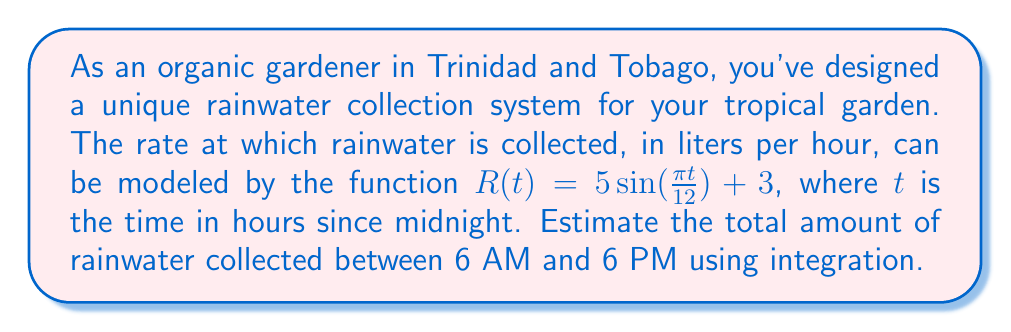Help me with this question. To solve this problem, we need to integrate the rate function $R(t)$ over the given time interval. Let's break it down step by step:

1) First, we need to set up the definite integral. The limits of integration are from 6 AM (6 hours after midnight) to 6 PM (18 hours after midnight):

   $$\int_{6}^{18} R(t) dt = \int_{6}^{18} (5\sin(\frac{\pi t}{12}) + 3) dt$$

2) We can split this into two integrals:

   $$\int_{6}^{18} 5\sin(\frac{\pi t}{12}) dt + \int_{6}^{18} 3 dt$$

3) Let's solve the second integral first, as it's simpler:

   $$\int_{6}^{18} 3 dt = 3t \big|_{6}^{18} = 3(18) - 3(6) = 54 - 18 = 36$$

4) Now for the first integral, we need to use substitution. Let $u = \frac{\pi t}{12}$, then $du = \frac{\pi}{12} dt$ or $dt = \frac{12}{\pi} du$:

   $$5\int_{6}^{18} \sin(\frac{\pi t}{12}) dt = 5 \cdot \frac{12}{\pi} \int_{\frac{\pi}{2}}^{\frac{3\pi}{2}} \sin(u) du$$

5) We can solve this integral:

   $$5 \cdot \frac{12}{\pi} [-\cos(u)]_{\frac{\pi}{2}}^{\frac{3\pi}{2}} = 5 \cdot \frac{12}{\pi} [(-\cos(\frac{3\pi}{2})) - (-\cos(\frac{\pi}{2}))]$$
   
   $$= 5 \cdot \frac{12}{\pi} [0 - 0] = 0$$

6) Adding the results from steps 3 and 5:

   Total rainwater collected = 36 + 0 = 36 liters
Answer: The total amount of rainwater collected between 6 AM and 6 PM is approximately 36 liters. 